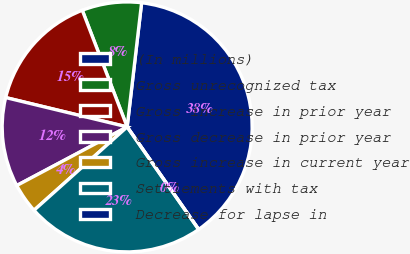Convert chart. <chart><loc_0><loc_0><loc_500><loc_500><pie_chart><fcel>(In millions)<fcel>Gross unrecognized tax<fcel>Gross increase in prior year<fcel>Gross decrease in prior year<fcel>Gross increase in current year<fcel>Settlements with tax<fcel>Decrease for lapse in<nl><fcel>38.46%<fcel>7.69%<fcel>15.38%<fcel>11.54%<fcel>3.85%<fcel>23.07%<fcel>0.0%<nl></chart> 